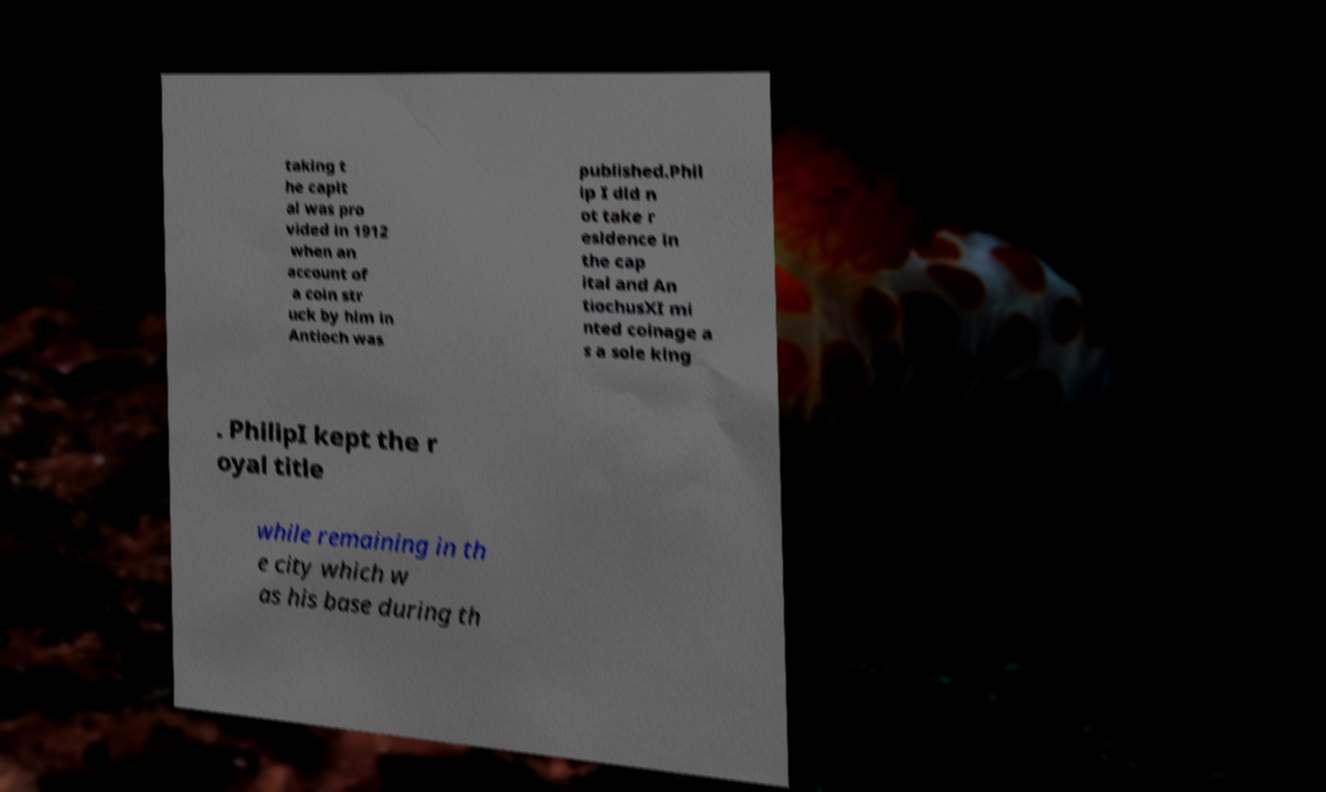For documentation purposes, I need the text within this image transcribed. Could you provide that? taking t he capit al was pro vided in 1912 when an account of a coin str uck by him in Antioch was published.Phil ip I did n ot take r esidence in the cap ital and An tiochusXI mi nted coinage a s a sole king . PhilipI kept the r oyal title while remaining in th e city which w as his base during th 